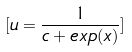Convert formula to latex. <formula><loc_0><loc_0><loc_500><loc_500>[ u = \frac { 1 } { c + e x p ( x ) } ]</formula> 